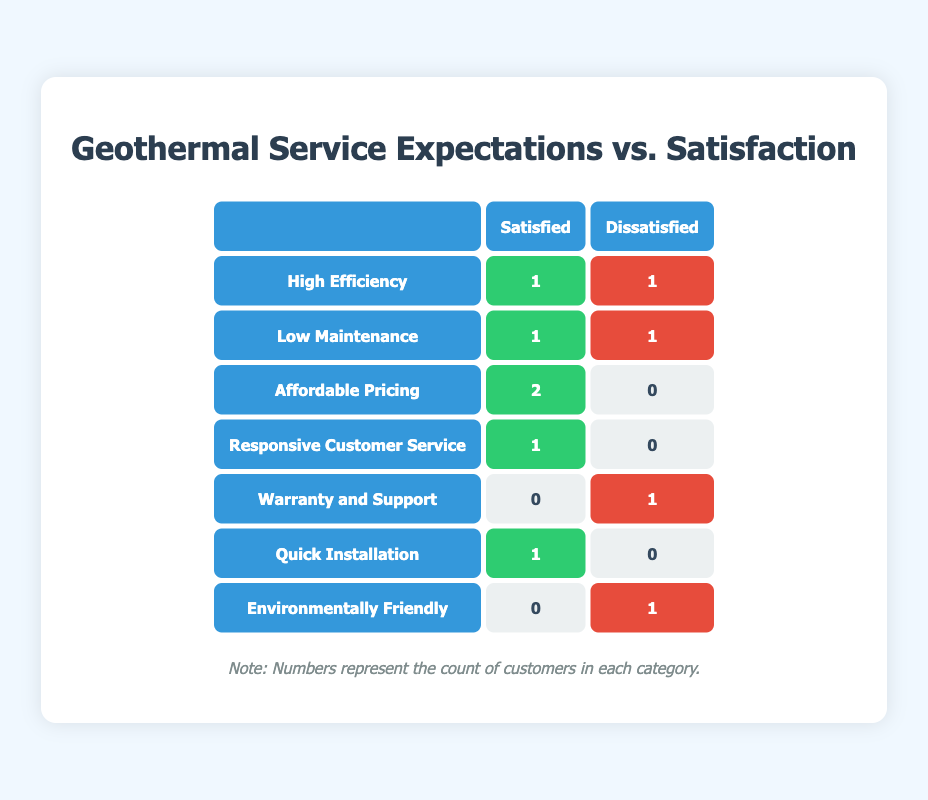What is the total number of customers that had high efficiency as an expectation? The table shows "High Efficiency" with 1 customer satisfied and 1 customer dissatisfied. By adding these two numbers together, we find the total as 1 + 1 = 2.
Answer: 2 How many customers were satisfied with affordable pricing? The table indicates that for "Affordable Pricing," there are 2 customers satisfied and none dissatisfied. Thus, the number of satisfied customers is directly taken from the table.
Answer: 2 Are more customers satisfied or dissatisfied with low maintenance? For "Low Maintenance," there is 1 customer satisfied and 1 customer dissatisfied. Since the numbers are equal, we find that neither group has more customers than the other.
Answer: No What is the total count of dissatisfied customers across all expectations? We need to count the dissatisfied customers in the table. There is 1 each for "Low Maintenance," "Warranty and Support," and "Environmentally Friendly," giving us a total of 1 + 1 + 1 = 3 dissatisfied customers.
Answer: 3 Which expectation had the highest rate of satisfaction and what was that rate? Looking at the table, "Affordable Pricing" shows 2 satisfied and 0 dissatisfied customers, indicating a satisfaction rate of 100%. To confirm it's the highest, we observe that no other expectation has more than 1 satisfied customer, making it the highest rate overall.
Answer: 100% How many customers were satisfied with responsive customer service? The table has a specific entry for "Responsive Customer Service," showing there is 1 customer satisfied and none who are dissatisfied. Therefore, we directly refer to the table for the answer.
Answer: 1 Is there any expectation where no customers were satisfied? Checking the table, "Warranty and Support" and "Environmentally Friendly" show 0 customers satisfied. Thus, we can confirm there are expectations where satisfaction is absent.
Answer: Yes What is the difference in the number of satisfied customers between "High Efficiency" and "Quick Installation"? The table shows "High Efficiency" has 1 satisfied customer, while "Quick Installation" also has 1 satisfied customer. The difference is therefore 1 - 1 = 0.
Answer: 0 What percentage of customers were satisfied under the expectation "Environmentally Friendly"? There are 0 satisfied customers and 1 dissatisfied customer for this expectation. To calculate the percentage, we take the number of satisfied customers (0), divide by the total (0 + 1 = 1), which leads to 0/1 = 0%. Hence, the percentage of satisfied customers is 0%.
Answer: 0% 